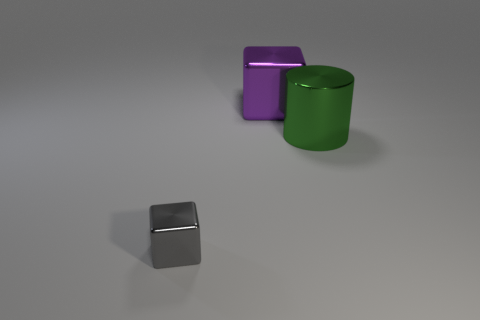What is the shape of the thing behind the thing that is on the right side of the block that is to the right of the tiny thing? The item behind the cylinder, which is to the right of the gray cube (the tiny thing), is a cube. Its clean, straight edges and identical square faces identify its shape precisely. 